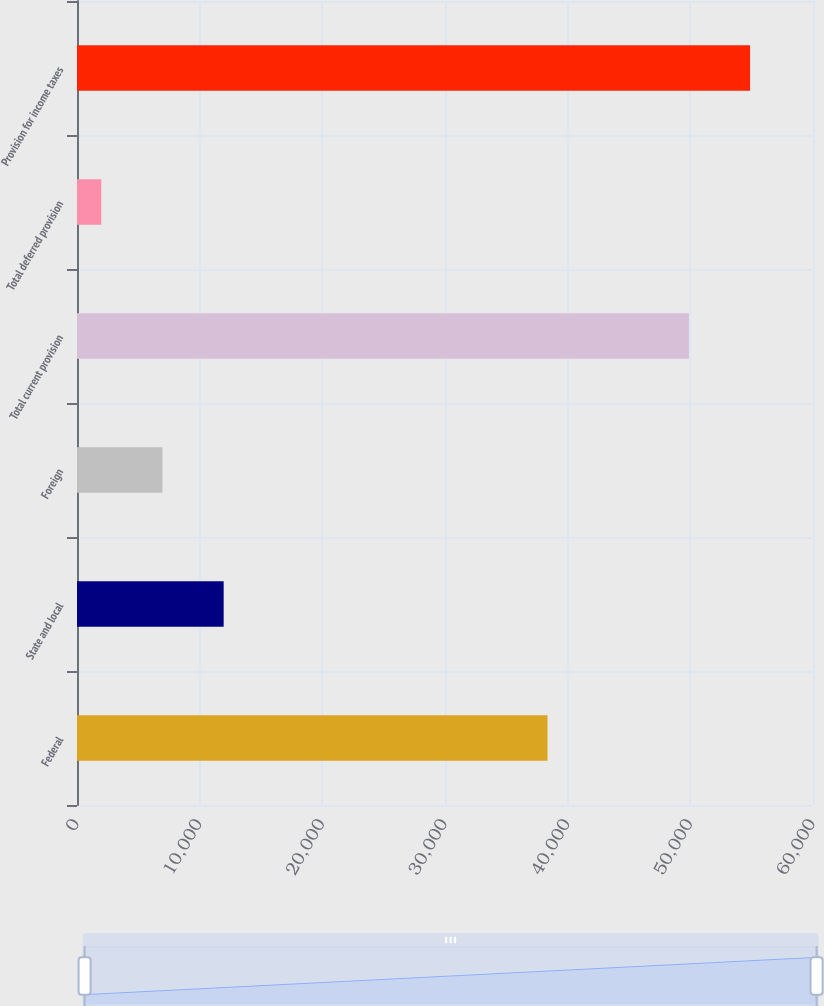Convert chart to OTSL. <chart><loc_0><loc_0><loc_500><loc_500><bar_chart><fcel>Federal<fcel>State and local<fcel>Foreign<fcel>Total current provision<fcel>Total deferred provision<fcel>Provision for income taxes<nl><fcel>38357<fcel>11956.6<fcel>6968.3<fcel>49883<fcel>1980<fcel>54871.3<nl></chart> 